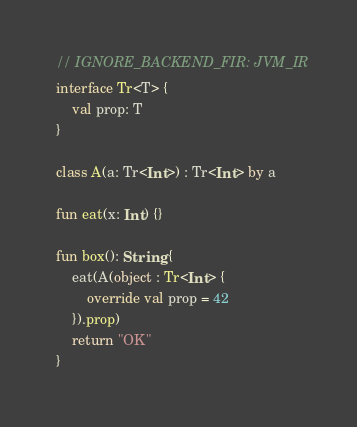Convert code to text. <code><loc_0><loc_0><loc_500><loc_500><_Kotlin_>// IGNORE_BACKEND_FIR: JVM_IR
interface Tr<T> {
    val prop: T
}

class A(a: Tr<Int>) : Tr<Int> by a

fun eat(x: Int) {}

fun box(): String {
    eat(A(object : Tr<Int> {
        override val prop = 42
    }).prop)
    return "OK"
}
</code> 